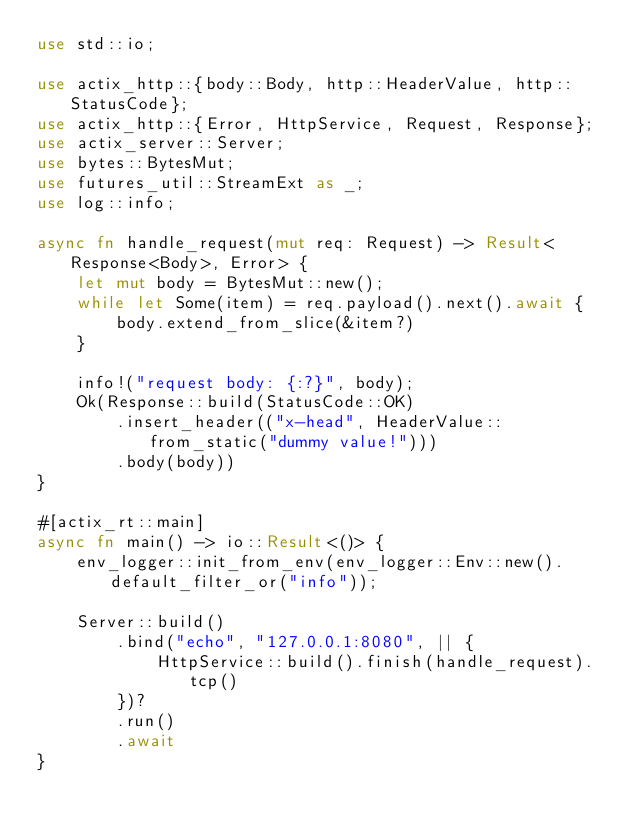<code> <loc_0><loc_0><loc_500><loc_500><_Rust_>use std::io;

use actix_http::{body::Body, http::HeaderValue, http::StatusCode};
use actix_http::{Error, HttpService, Request, Response};
use actix_server::Server;
use bytes::BytesMut;
use futures_util::StreamExt as _;
use log::info;

async fn handle_request(mut req: Request) -> Result<Response<Body>, Error> {
    let mut body = BytesMut::new();
    while let Some(item) = req.payload().next().await {
        body.extend_from_slice(&item?)
    }

    info!("request body: {:?}", body);
    Ok(Response::build(StatusCode::OK)
        .insert_header(("x-head", HeaderValue::from_static("dummy value!")))
        .body(body))
}

#[actix_rt::main]
async fn main() -> io::Result<()> {
    env_logger::init_from_env(env_logger::Env::new().default_filter_or("info"));

    Server::build()
        .bind("echo", "127.0.0.1:8080", || {
            HttpService::build().finish(handle_request).tcp()
        })?
        .run()
        .await
}
</code> 